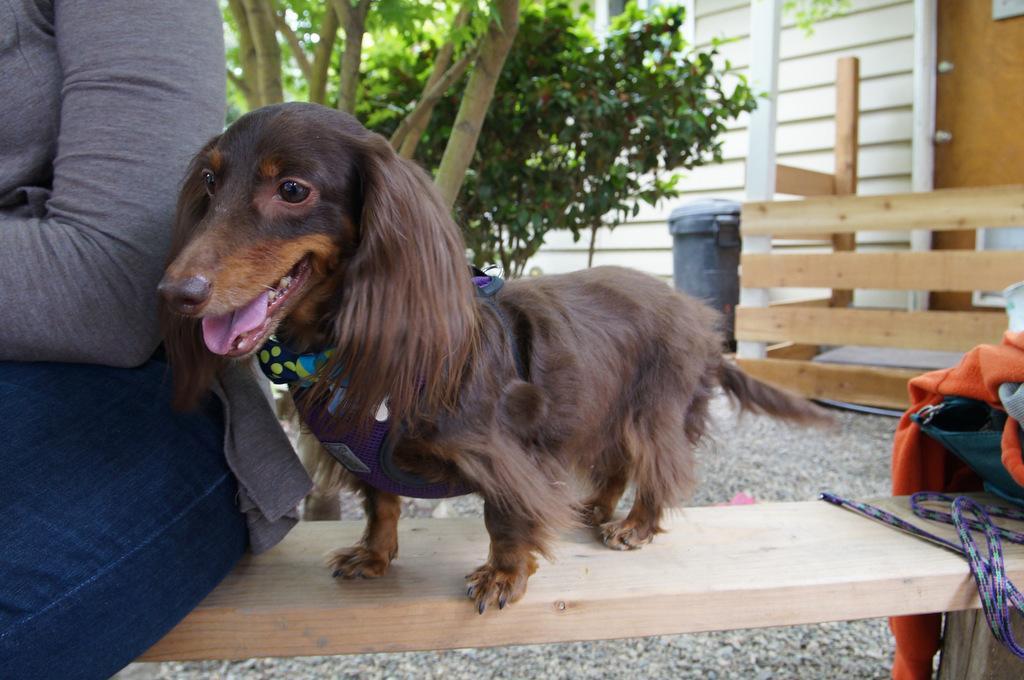In one or two sentences, can you explain what this image depicts? In this image I can see the dog and the dog is in brown color, I can also see the person sitting on the wooden surface. Background I can see trees in green color and I can see the wooden railing. 